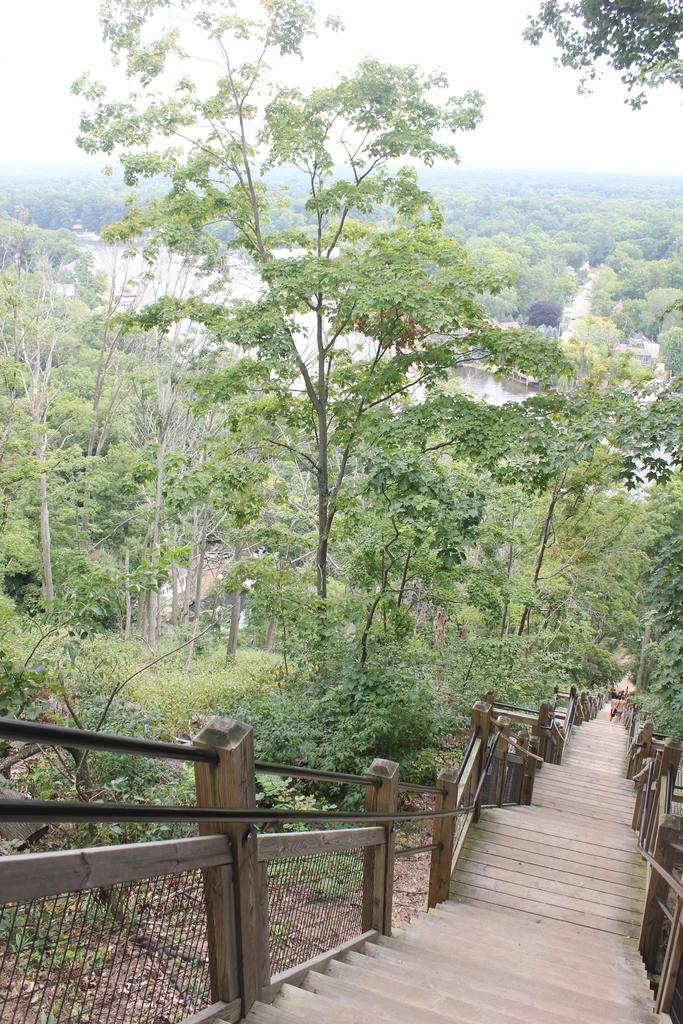In one or two sentences, can you explain what this image depicts? At the bottom of this image I can see the stairs. On both sides of the stairs, I can see the hand railings. In the background there are many trees and also there is a sea. At the top of the image I can see the sky. 